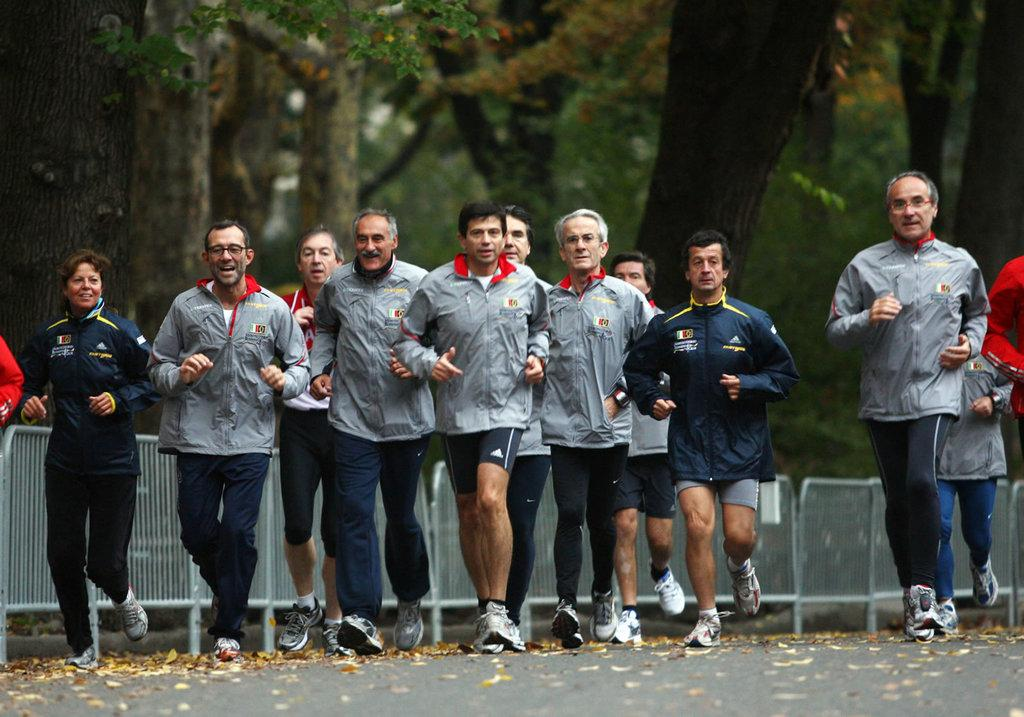What are the persons in the image doing? The persons in the image are running on the road. What can be seen on the ground in the image? Dry leaves are present on the ground. What is visible in the background of the image? There is a fence and trees visible in the background of the image. What type of vessel is being used to transport water in the image? There is no vessel or water present in the image; it features persons running on the road with dry leaves on the ground and a fence and trees in the background. 